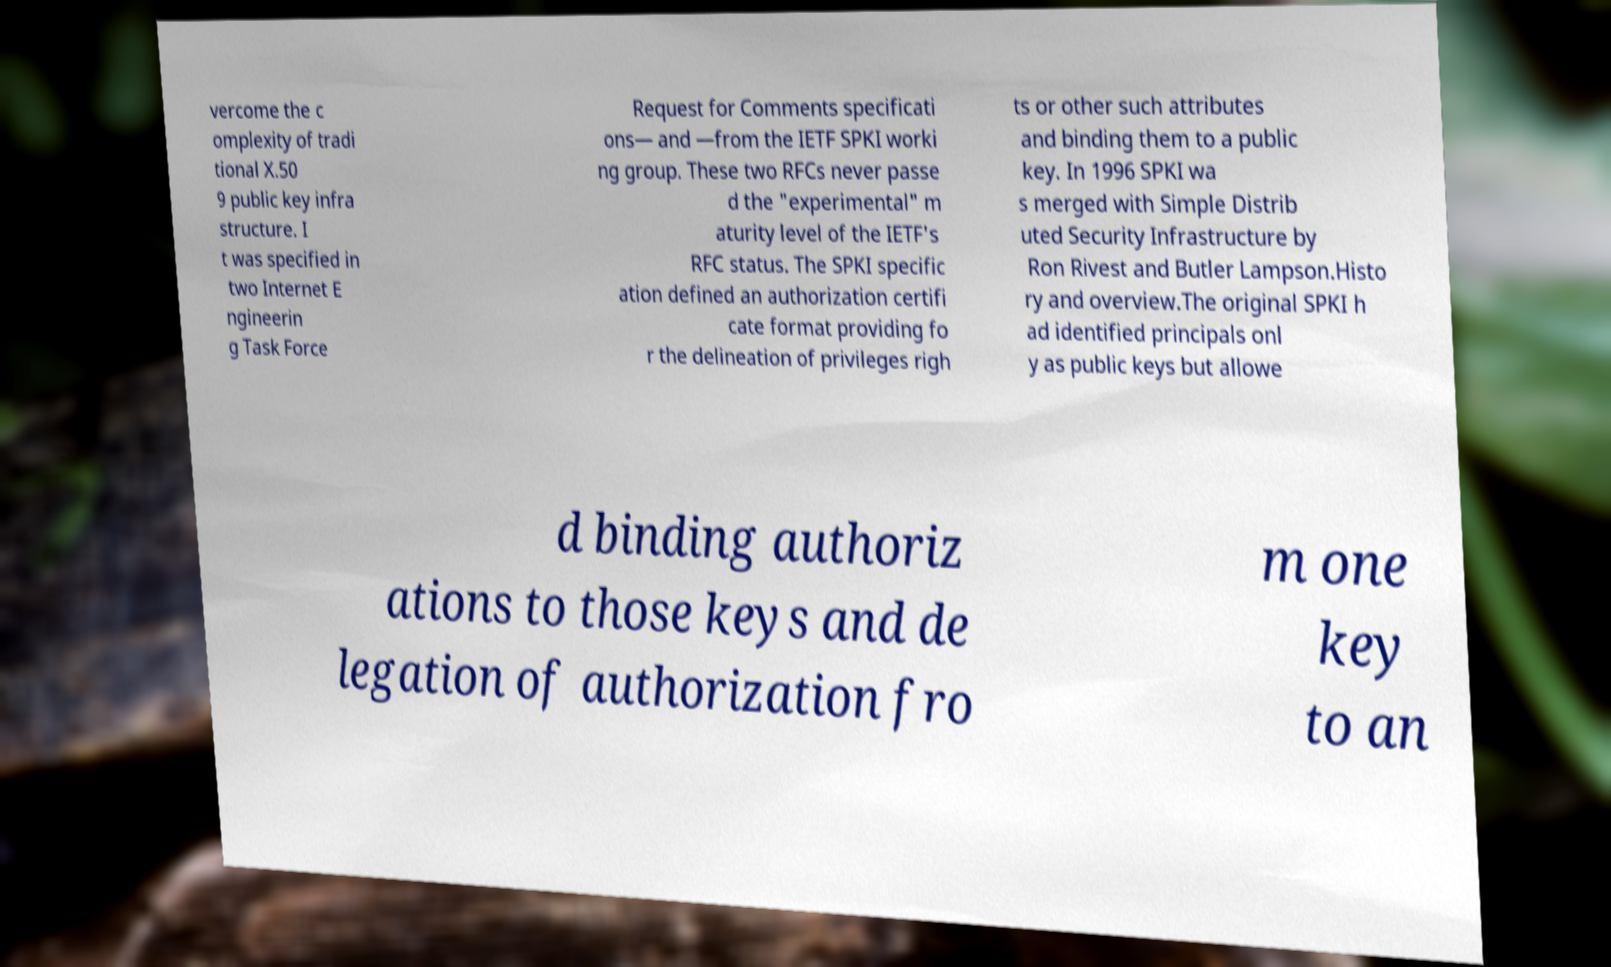Please read and relay the text visible in this image. What does it say? vercome the c omplexity of tradi tional X.50 9 public key infra structure. I t was specified in two Internet E ngineerin g Task Force Request for Comments specificati ons— and —from the IETF SPKI worki ng group. These two RFCs never passe d the "experimental" m aturity level of the IETF's RFC status. The SPKI specific ation defined an authorization certifi cate format providing fo r the delineation of privileges righ ts or other such attributes and binding them to a public key. In 1996 SPKI wa s merged with Simple Distrib uted Security Infrastructure by Ron Rivest and Butler Lampson.Histo ry and overview.The original SPKI h ad identified principals onl y as public keys but allowe d binding authoriz ations to those keys and de legation of authorization fro m one key to an 